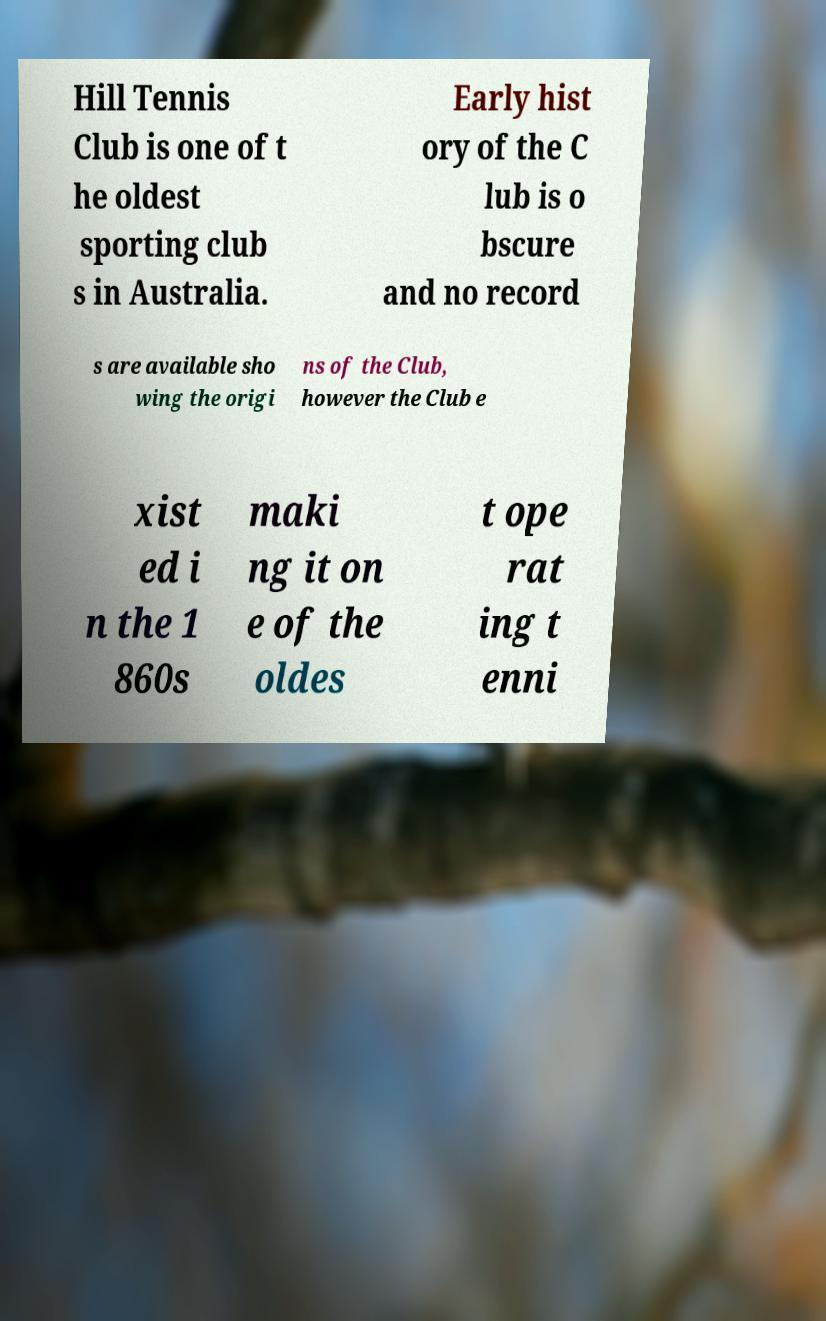There's text embedded in this image that I need extracted. Can you transcribe it verbatim? Hill Tennis Club is one of t he oldest sporting club s in Australia. Early hist ory of the C lub is o bscure and no record s are available sho wing the origi ns of the Club, however the Club e xist ed i n the 1 860s maki ng it on e of the oldes t ope rat ing t enni 